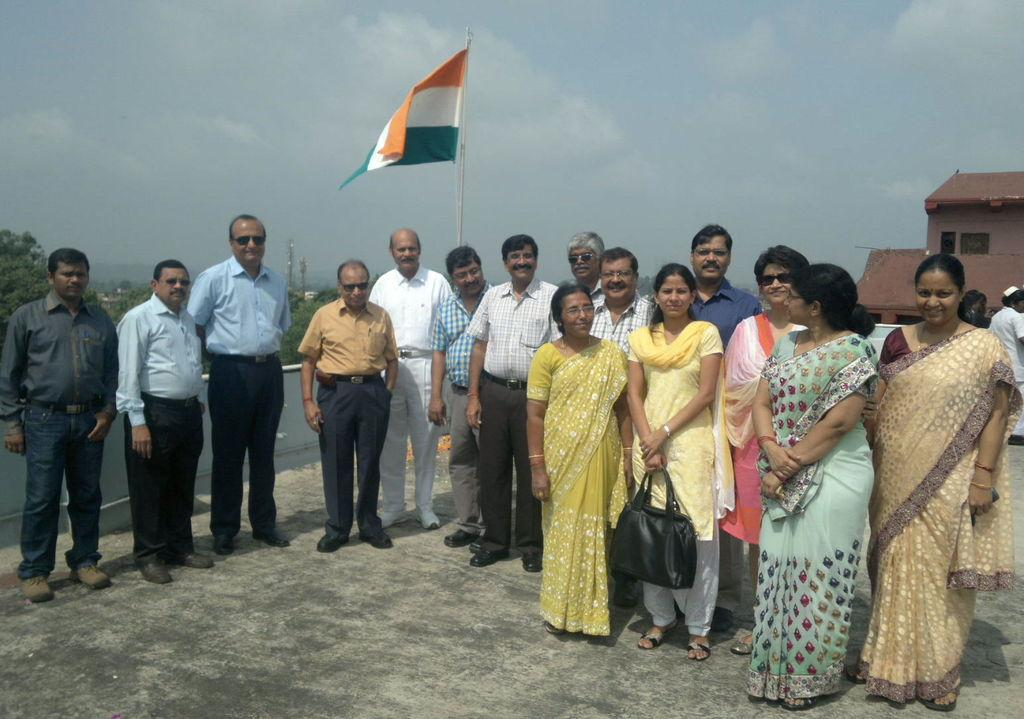How many people are in the image? There are people in the image, but the exact number is not specified. What is the background of the image? The people are standing in front of a flag. What are the people doing in the image? The people are looking at someone. What type of salt is being used in the operation depicted in the image? There is no operation or salt present in the image. What type of approval is being sought by the people in the image? There is no indication in the image that the people are seeking approval for anything. 